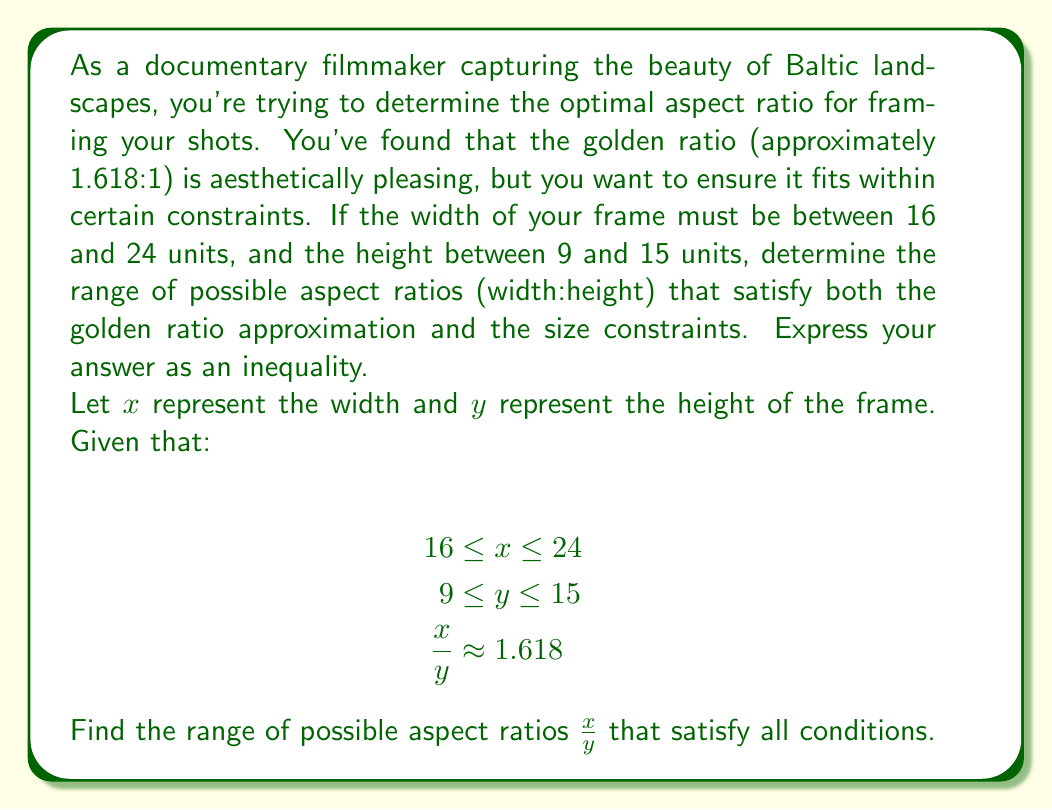Provide a solution to this math problem. To solve this problem, we'll follow these steps:

1) First, let's consider the constraints on $x$ and $y$:
   $16 \leq x \leq 24$
   $9 \leq y \leq 15$

2) The aspect ratio is given by $\frac{x}{y}$. We need to find the minimum and maximum possible values for this ratio.

3) The minimum aspect ratio will occur when $x$ is at its minimum and $y$ is at its maximum:
   
   $$\text{Min ratio} = \frac{16}{15} \approx 1.067$$

4) The maximum aspect ratio will occur when $x$ is at its maximum and $y$ is at its minimum:
   
   $$\text{Max ratio} = \frac{24}{9} = \frac{8}{3} \approx 2.667$$

5) Now, we need to check if the golden ratio (approximately 1.618) falls within this range. Indeed it does, as $1.067 < 1.618 < 2.667$.

6) Therefore, the range of possible aspect ratios that satisfy both the golden ratio approximation and the size constraints can be expressed as an inequality:

   $$\frac{16}{15} \leq \frac{x}{y} \leq \frac{8}{3}$$

This inequality represents all possible aspect ratios within the given constraints, including the golden ratio.
Answer: $$\frac{16}{15} \leq \frac{x}{y} \leq \frac{8}{3}$$ 